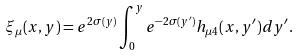Convert formula to latex. <formula><loc_0><loc_0><loc_500><loc_500>\xi _ { \mu } ( x , y ) = e ^ { 2 \sigma ( y ) } \int _ { 0 } ^ { y } e ^ { - 2 \sigma ( y ^ { \prime } ) } h _ { \mu 4 } ( x , y ^ { \prime } ) d y ^ { \prime } .</formula> 